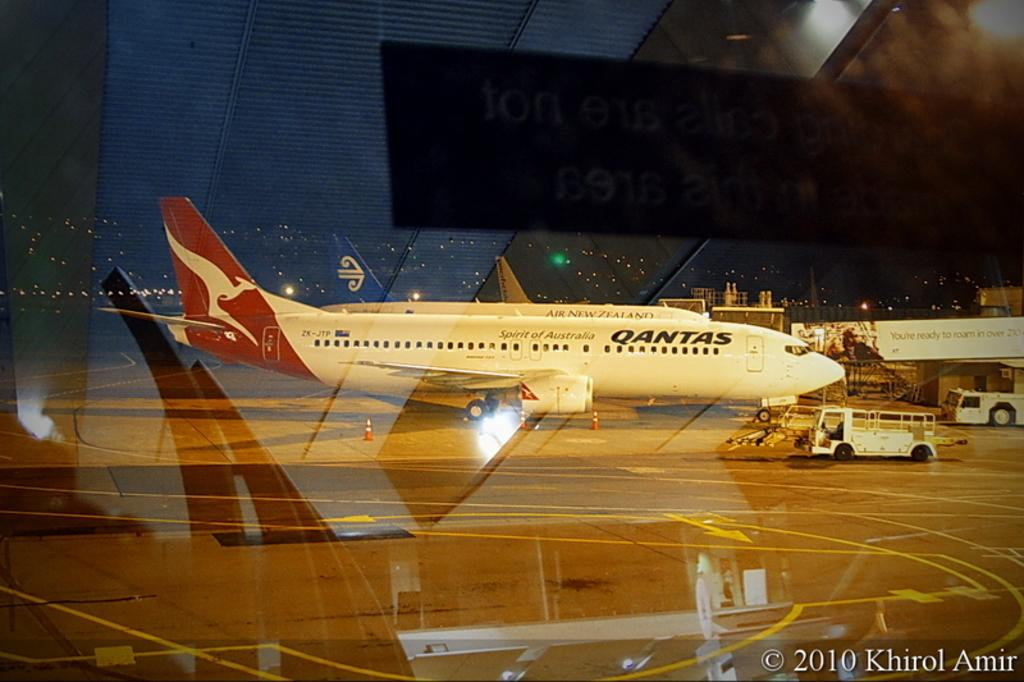<image>
Summarize the visual content of the image. A Qantas commercial jet is parked at an airport at night. 